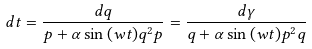<formula> <loc_0><loc_0><loc_500><loc_500>d t = \frac { d q } { p + \alpha \sin { ( w t ) } q ^ { 2 } p } = \frac { d \gamma } { q + \alpha \sin { ( w t ) } p ^ { 2 } q }</formula> 